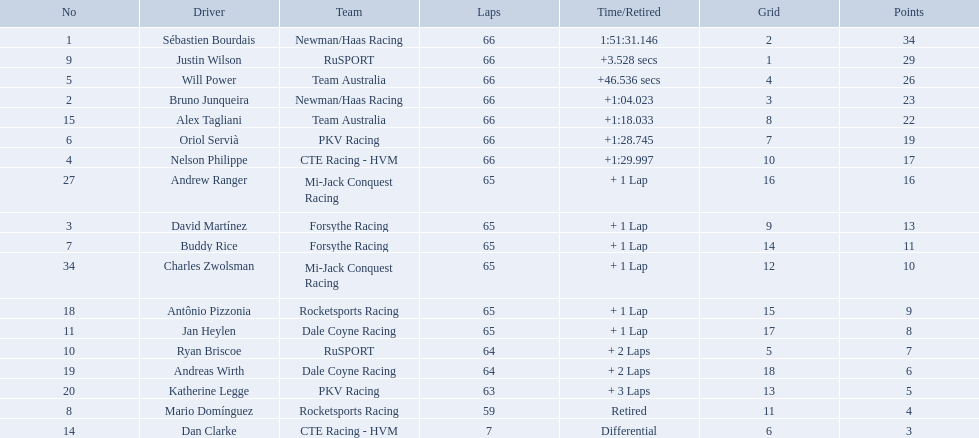What drivers started in the top 10? Sébastien Bourdais, Justin Wilson, Will Power, Bruno Junqueira, Alex Tagliani, Oriol Servià, Nelson Philippe, Ryan Briscoe, Dan Clarke. Which of those drivers completed all 66 laps? Sébastien Bourdais, Justin Wilson, Will Power, Bruno Junqueira, Alex Tagliani, Oriol Servià, Nelson Philippe. Whom of these did not drive for team australia? Sébastien Bourdais, Justin Wilson, Bruno Junqueira, Oriol Servià, Nelson Philippe. Which of these drivers finished more then a minuet after the winner? Bruno Junqueira, Oriol Servià, Nelson Philippe. Which of these drivers had the highest car number? Oriol Servià. What was the highest amount of points scored in the 2006 gran premio? 34. Who scored 34 points? Sébastien Bourdais. Which drivers scored at least 10 points? Sébastien Bourdais, Justin Wilson, Will Power, Bruno Junqueira, Alex Tagliani, Oriol Servià, Nelson Philippe, Andrew Ranger, David Martínez, Buddy Rice, Charles Zwolsman. Of those drivers, which ones scored at least 20 points? Sébastien Bourdais, Justin Wilson, Will Power, Bruno Junqueira, Alex Tagliani. Of those 5, which driver scored the most points? Sébastien Bourdais. What are the drivers numbers? 1, 9, 5, 2, 15, 6, 4, 27, 3, 7, 34, 18, 11, 10, 19, 20, 8, 14. Are there any who's number matches his position? Sébastien Bourdais, Oriol Servià. Of those two who has the highest position? Sébastien Bourdais. Would you be able to parse every entry in this table? {'header': ['No', 'Driver', 'Team', 'Laps', 'Time/Retired', 'Grid', 'Points'], 'rows': [['1', 'Sébastien Bourdais', 'Newman/Haas Racing', '66', '1:51:31.146', '2', '34'], ['9', 'Justin Wilson', 'RuSPORT', '66', '+3.528 secs', '1', '29'], ['5', 'Will Power', 'Team Australia', '66', '+46.536 secs', '4', '26'], ['2', 'Bruno Junqueira', 'Newman/Haas Racing', '66', '+1:04.023', '3', '23'], ['15', 'Alex Tagliani', 'Team Australia', '66', '+1:18.033', '8', '22'], ['6', 'Oriol Servià', 'PKV Racing', '66', '+1:28.745', '7', '19'], ['4', 'Nelson Philippe', 'CTE Racing - HVM', '66', '+1:29.997', '10', '17'], ['27', 'Andrew Ranger', 'Mi-Jack Conquest Racing', '65', '+ 1 Lap', '16', '16'], ['3', 'David Martínez', 'Forsythe Racing', '65', '+ 1 Lap', '9', '13'], ['7', 'Buddy Rice', 'Forsythe Racing', '65', '+ 1 Lap', '14', '11'], ['34', 'Charles Zwolsman', 'Mi-Jack Conquest Racing', '65', '+ 1 Lap', '12', '10'], ['18', 'Antônio Pizzonia', 'Rocketsports Racing', '65', '+ 1 Lap', '15', '9'], ['11', 'Jan Heylen', 'Dale Coyne Racing', '65', '+ 1 Lap', '17', '8'], ['10', 'Ryan Briscoe', 'RuSPORT', '64', '+ 2 Laps', '5', '7'], ['19', 'Andreas Wirth', 'Dale Coyne Racing', '64', '+ 2 Laps', '18', '6'], ['20', 'Katherine Legge', 'PKV Racing', '63', '+ 3 Laps', '13', '5'], ['8', 'Mario Domínguez', 'Rocketsports Racing', '59', 'Retired', '11', '4'], ['14', 'Dan Clarke', 'CTE Racing - HVM', '7', 'Differential', '6', '3']]} Who are all the drivers? Sébastien Bourdais, Justin Wilson, Will Power, Bruno Junqueira, Alex Tagliani, Oriol Servià, Nelson Philippe, Andrew Ranger, David Martínez, Buddy Rice, Charles Zwolsman, Antônio Pizzonia, Jan Heylen, Ryan Briscoe, Andreas Wirth, Katherine Legge, Mario Domínguez, Dan Clarke. What position did they reach? 1, 2, 3, 4, 5, 6, 7, 8, 9, 10, 11, 12, 13, 14, 15, 16, 17, 18. What is the number for each driver? 1, 9, 5, 2, 15, 6, 4, 27, 3, 7, 34, 18, 11, 10, 19, 20, 8, 14. And which player's number and position match? Sébastien Bourdais. 